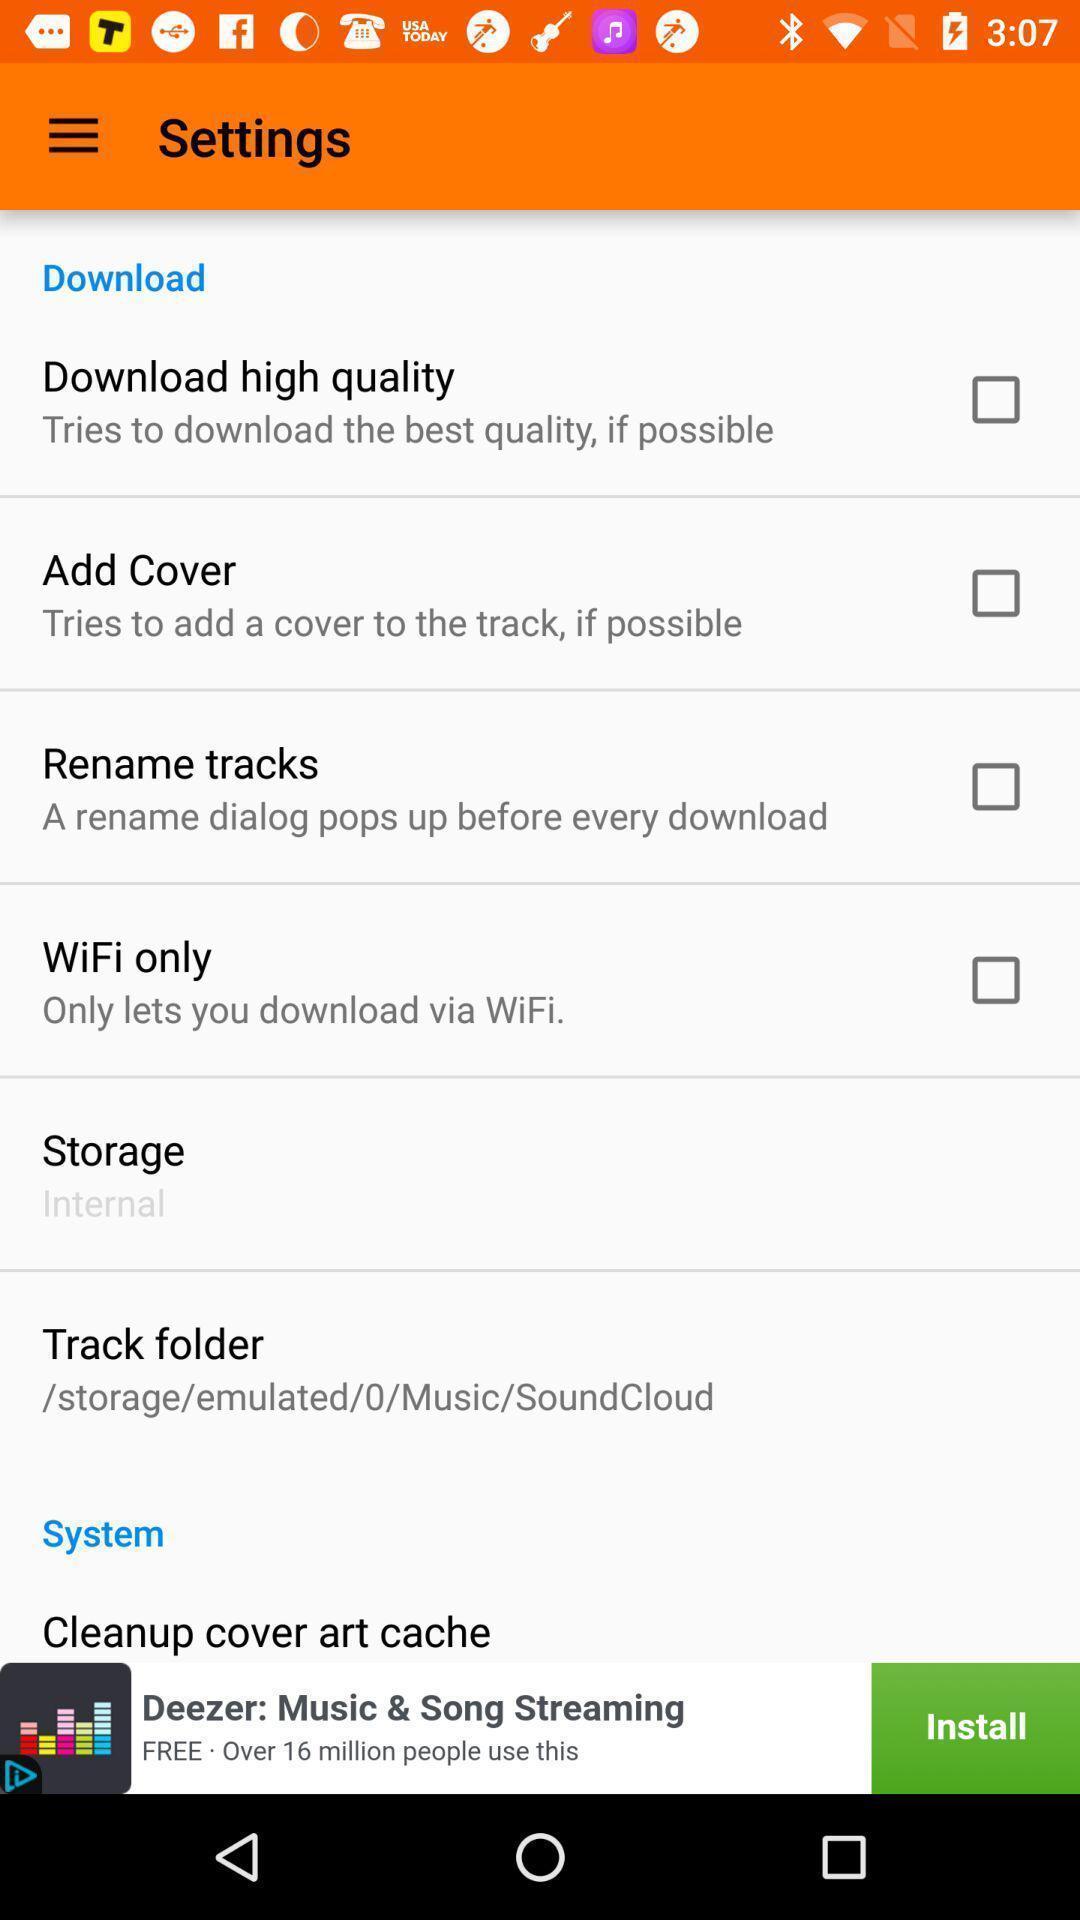Tell me what you see in this picture. Various setting options. 